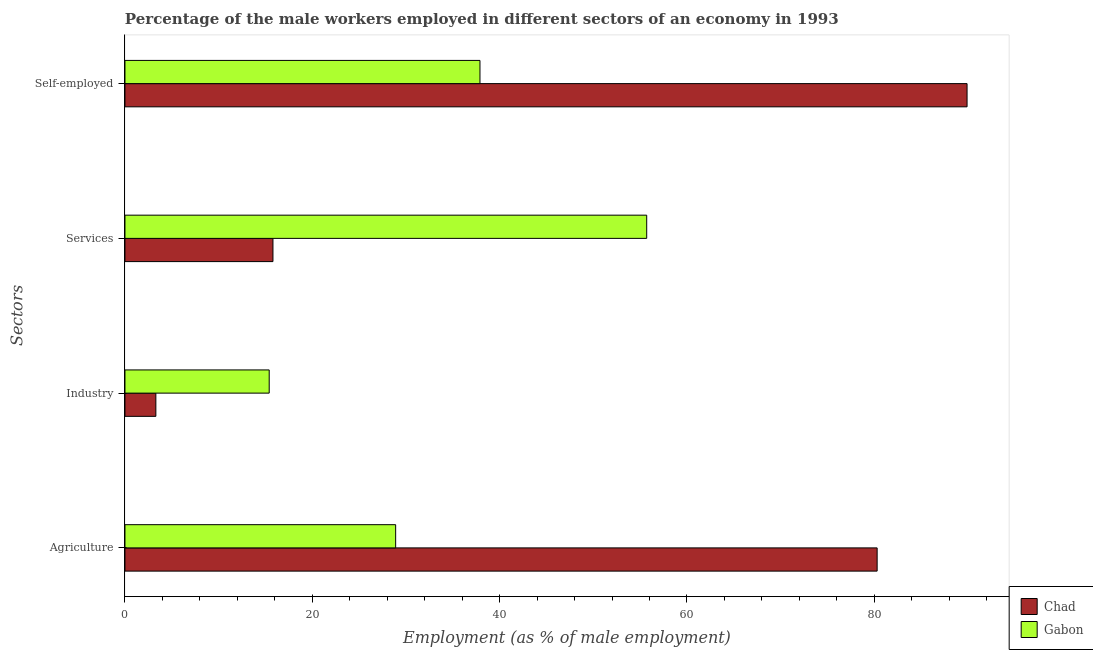Are the number of bars per tick equal to the number of legend labels?
Give a very brief answer. Yes. Are the number of bars on each tick of the Y-axis equal?
Keep it short and to the point. Yes. How many bars are there on the 4th tick from the bottom?
Make the answer very short. 2. What is the label of the 3rd group of bars from the top?
Your answer should be compact. Industry. What is the percentage of male workers in services in Gabon?
Your response must be concise. 55.7. Across all countries, what is the maximum percentage of male workers in services?
Ensure brevity in your answer.  55.7. Across all countries, what is the minimum percentage of male workers in services?
Offer a terse response. 15.8. In which country was the percentage of self employed male workers maximum?
Make the answer very short. Chad. In which country was the percentage of male workers in industry minimum?
Provide a short and direct response. Chad. What is the total percentage of male workers in services in the graph?
Your answer should be compact. 71.5. What is the difference between the percentage of male workers in services in Chad and that in Gabon?
Your answer should be compact. -39.9. What is the difference between the percentage of male workers in industry in Gabon and the percentage of male workers in services in Chad?
Offer a terse response. -0.4. What is the average percentage of self employed male workers per country?
Keep it short and to the point. 63.9. What is the difference between the percentage of male workers in services and percentage of self employed male workers in Chad?
Your answer should be very brief. -74.1. In how many countries, is the percentage of male workers in agriculture greater than 48 %?
Provide a short and direct response. 1. What is the ratio of the percentage of male workers in industry in Gabon to that in Chad?
Your answer should be compact. 4.67. What is the difference between the highest and the second highest percentage of self employed male workers?
Offer a very short reply. 52. What is the difference between the highest and the lowest percentage of male workers in services?
Your response must be concise. 39.9. In how many countries, is the percentage of male workers in industry greater than the average percentage of male workers in industry taken over all countries?
Your answer should be very brief. 1. What does the 1st bar from the top in Services represents?
Your answer should be very brief. Gabon. What does the 1st bar from the bottom in Services represents?
Offer a terse response. Chad. Is it the case that in every country, the sum of the percentage of male workers in agriculture and percentage of male workers in industry is greater than the percentage of male workers in services?
Your response must be concise. No. Are the values on the major ticks of X-axis written in scientific E-notation?
Your response must be concise. No. Does the graph contain any zero values?
Offer a terse response. No. Does the graph contain grids?
Give a very brief answer. No. Where does the legend appear in the graph?
Your answer should be very brief. Bottom right. How are the legend labels stacked?
Your answer should be compact. Vertical. What is the title of the graph?
Make the answer very short. Percentage of the male workers employed in different sectors of an economy in 1993. What is the label or title of the X-axis?
Make the answer very short. Employment (as % of male employment). What is the label or title of the Y-axis?
Offer a very short reply. Sectors. What is the Employment (as % of male employment) of Chad in Agriculture?
Your answer should be compact. 80.3. What is the Employment (as % of male employment) of Gabon in Agriculture?
Offer a very short reply. 28.9. What is the Employment (as % of male employment) in Chad in Industry?
Provide a succinct answer. 3.3. What is the Employment (as % of male employment) of Gabon in Industry?
Offer a very short reply. 15.4. What is the Employment (as % of male employment) of Chad in Services?
Give a very brief answer. 15.8. What is the Employment (as % of male employment) of Gabon in Services?
Provide a short and direct response. 55.7. What is the Employment (as % of male employment) in Chad in Self-employed?
Give a very brief answer. 89.9. What is the Employment (as % of male employment) of Gabon in Self-employed?
Offer a terse response. 37.9. Across all Sectors, what is the maximum Employment (as % of male employment) in Chad?
Your response must be concise. 89.9. Across all Sectors, what is the maximum Employment (as % of male employment) of Gabon?
Give a very brief answer. 55.7. Across all Sectors, what is the minimum Employment (as % of male employment) of Chad?
Make the answer very short. 3.3. Across all Sectors, what is the minimum Employment (as % of male employment) of Gabon?
Make the answer very short. 15.4. What is the total Employment (as % of male employment) in Chad in the graph?
Your response must be concise. 189.3. What is the total Employment (as % of male employment) of Gabon in the graph?
Provide a short and direct response. 137.9. What is the difference between the Employment (as % of male employment) of Chad in Agriculture and that in Industry?
Your answer should be very brief. 77. What is the difference between the Employment (as % of male employment) in Chad in Agriculture and that in Services?
Keep it short and to the point. 64.5. What is the difference between the Employment (as % of male employment) of Gabon in Agriculture and that in Services?
Give a very brief answer. -26.8. What is the difference between the Employment (as % of male employment) in Gabon in Agriculture and that in Self-employed?
Offer a terse response. -9. What is the difference between the Employment (as % of male employment) in Gabon in Industry and that in Services?
Make the answer very short. -40.3. What is the difference between the Employment (as % of male employment) in Chad in Industry and that in Self-employed?
Give a very brief answer. -86.6. What is the difference between the Employment (as % of male employment) of Gabon in Industry and that in Self-employed?
Your answer should be compact. -22.5. What is the difference between the Employment (as % of male employment) of Chad in Services and that in Self-employed?
Your answer should be compact. -74.1. What is the difference between the Employment (as % of male employment) of Gabon in Services and that in Self-employed?
Your answer should be compact. 17.8. What is the difference between the Employment (as % of male employment) in Chad in Agriculture and the Employment (as % of male employment) in Gabon in Industry?
Provide a short and direct response. 64.9. What is the difference between the Employment (as % of male employment) of Chad in Agriculture and the Employment (as % of male employment) of Gabon in Services?
Your response must be concise. 24.6. What is the difference between the Employment (as % of male employment) in Chad in Agriculture and the Employment (as % of male employment) in Gabon in Self-employed?
Keep it short and to the point. 42.4. What is the difference between the Employment (as % of male employment) of Chad in Industry and the Employment (as % of male employment) of Gabon in Services?
Ensure brevity in your answer.  -52.4. What is the difference between the Employment (as % of male employment) in Chad in Industry and the Employment (as % of male employment) in Gabon in Self-employed?
Your answer should be very brief. -34.6. What is the difference between the Employment (as % of male employment) in Chad in Services and the Employment (as % of male employment) in Gabon in Self-employed?
Give a very brief answer. -22.1. What is the average Employment (as % of male employment) in Chad per Sectors?
Your answer should be very brief. 47.33. What is the average Employment (as % of male employment) of Gabon per Sectors?
Your answer should be very brief. 34.48. What is the difference between the Employment (as % of male employment) of Chad and Employment (as % of male employment) of Gabon in Agriculture?
Your answer should be very brief. 51.4. What is the difference between the Employment (as % of male employment) of Chad and Employment (as % of male employment) of Gabon in Services?
Your answer should be very brief. -39.9. What is the difference between the Employment (as % of male employment) in Chad and Employment (as % of male employment) in Gabon in Self-employed?
Keep it short and to the point. 52. What is the ratio of the Employment (as % of male employment) in Chad in Agriculture to that in Industry?
Your answer should be compact. 24.33. What is the ratio of the Employment (as % of male employment) in Gabon in Agriculture to that in Industry?
Your answer should be compact. 1.88. What is the ratio of the Employment (as % of male employment) in Chad in Agriculture to that in Services?
Provide a succinct answer. 5.08. What is the ratio of the Employment (as % of male employment) of Gabon in Agriculture to that in Services?
Ensure brevity in your answer.  0.52. What is the ratio of the Employment (as % of male employment) in Chad in Agriculture to that in Self-employed?
Your response must be concise. 0.89. What is the ratio of the Employment (as % of male employment) of Gabon in Agriculture to that in Self-employed?
Your response must be concise. 0.76. What is the ratio of the Employment (as % of male employment) in Chad in Industry to that in Services?
Make the answer very short. 0.21. What is the ratio of the Employment (as % of male employment) of Gabon in Industry to that in Services?
Keep it short and to the point. 0.28. What is the ratio of the Employment (as % of male employment) of Chad in Industry to that in Self-employed?
Make the answer very short. 0.04. What is the ratio of the Employment (as % of male employment) of Gabon in Industry to that in Self-employed?
Give a very brief answer. 0.41. What is the ratio of the Employment (as % of male employment) of Chad in Services to that in Self-employed?
Your answer should be very brief. 0.18. What is the ratio of the Employment (as % of male employment) of Gabon in Services to that in Self-employed?
Provide a succinct answer. 1.47. What is the difference between the highest and the second highest Employment (as % of male employment) of Chad?
Offer a terse response. 9.6. What is the difference between the highest and the second highest Employment (as % of male employment) of Gabon?
Make the answer very short. 17.8. What is the difference between the highest and the lowest Employment (as % of male employment) of Chad?
Provide a succinct answer. 86.6. What is the difference between the highest and the lowest Employment (as % of male employment) of Gabon?
Offer a terse response. 40.3. 